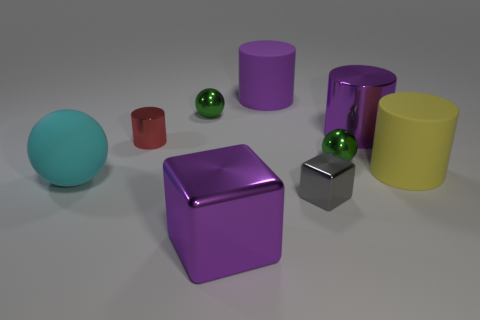Subtract all metallic balls. How many balls are left? 1 Subtract all brown balls. How many purple cylinders are left? 2 Subtract all yellow cylinders. How many cylinders are left? 3 Subtract 1 cylinders. How many cylinders are left? 3 Subtract all cylinders. How many objects are left? 5 Subtract all purple cylinders. Subtract all blue spheres. How many cylinders are left? 2 Subtract all tiny brown metal cubes. Subtract all large cyan spheres. How many objects are left? 8 Add 9 rubber spheres. How many rubber spheres are left? 10 Add 3 large rubber cylinders. How many large rubber cylinders exist? 5 Subtract 0 cyan cylinders. How many objects are left? 9 